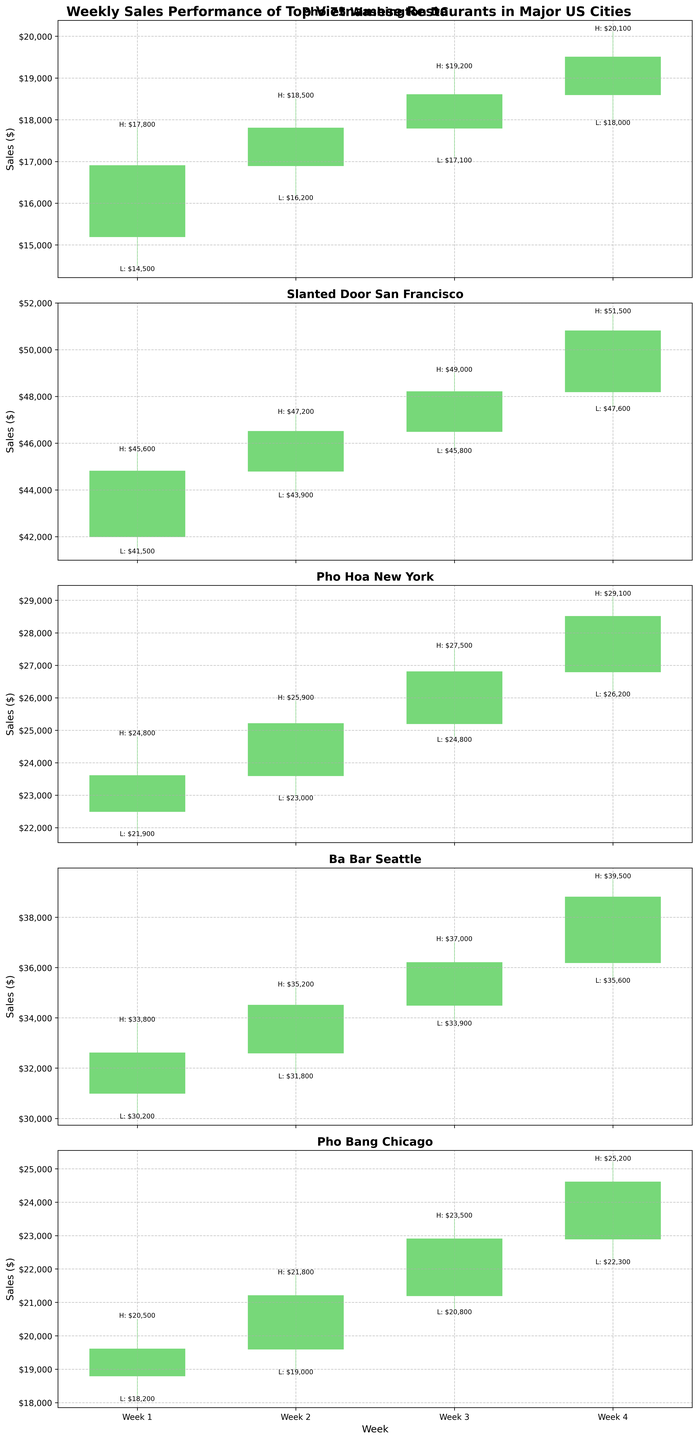What is the title of the overall chart? The title is located at the top center of the figure. It reads "Weekly Sales Performance of Top Vietnamese Restaurants in Major US Cities."
Answer: Weekly Sales Performance of Top Vietnamese Restaurants in Major US Cities Which restaurant shows the highest High value for any week? By visually examining the highest point reached by the candlesticks for each restaurant, we see that "Slanted Door San Francisco" in Week 4 has the highest High value of $51,500.
Answer: Slanted Door San Francisco Compare the sales performance in Week 3 across all restaurants. Which restaurant had the highest closing value? Look at the Week 3 Close values for all restaurants and identify the highest one: Pho 75 Washington DC ($18,600), Slanted Door San Francisco ($48,200), Pho Hoa New York ($26,800), Ba Bar Seattle ($36,200), Pho Bang Chicago ($22,900). "Slanted Door San Francisco" has the highest closing value in Week 3.
Answer: Slanted Door San Francisco Which restaurant had the most consistent (least volatile) sales in Week 1? Consistency can be observed by comparing the range (High - Low) for Week 1 across all restaurants: Pho 75 Washington DC ($1,800), Slanted Door San Francisco ($4,100), Pho Hoa New York ($2,900), Ba Bar Seattle ($3,600), Pho Bang Chicago ($2,300). "Pho 75 Washington DC" shows the smallest range of $1,800, indicating the most consistent sales.
Answer: Pho 75 Washington DC What was the trend of sales for "Ba Bar Seattle" over the 4 weeks? Observing the Close values for "Ba Bar Seattle" over Weeks 1 to 4: Week 1 ($32,600), Week 2 ($34,500), Week 3 ($36,200), Week 4 ($38,800), there's a clear increasing trend for the sales.
Answer: Increasing Which week had the lowest sales for "Pho Hoa New York"? Look at the Low values for "Pho Hoa New York" over the 4 weeks: Week 1 ($21,900), Week 2 ($23,000), Week 3 ($24,800), Week 4 ($26,200). Week 1 has the lowest value.
Answer: Week 1 How does the sales growth of "Pho Bang Chicago" compare between Week 2 and Week 3? Calculate the difference in Close values between Week 2 to Week 3 for "Pho Bang Chicago": Week 2 ($21,200) to Week 3 ($22,900). The growth is $1,700.
Answer: $1,700 Which restaurant had the highest Open value in Week 4? Compare the Open values for Week 4 across all restaurants: Pho 75 Washington DC ($18,600), Slanted Door San Francisco ($48,200), Pho Hoa New York ($26,800), Ba Bar Seattle ($36,200), Pho Bang Chicago ($22,900). "Slanted Door San Francisco" had the highest Open value.
Answer: Slanted Door San Francisco 